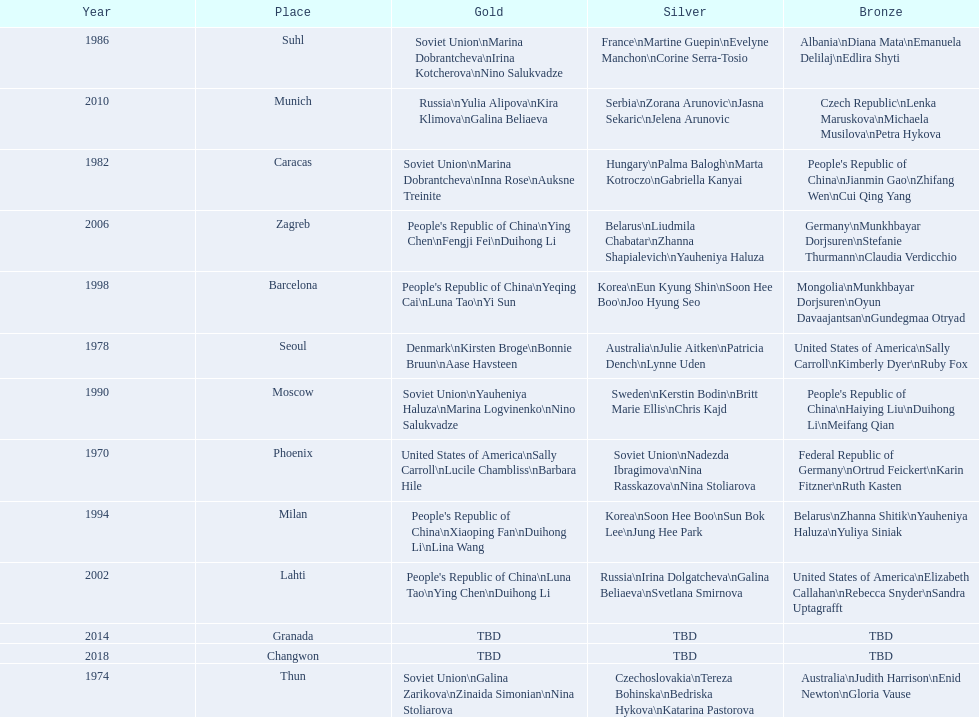What is the first place listed in this chart? Phoenix. 